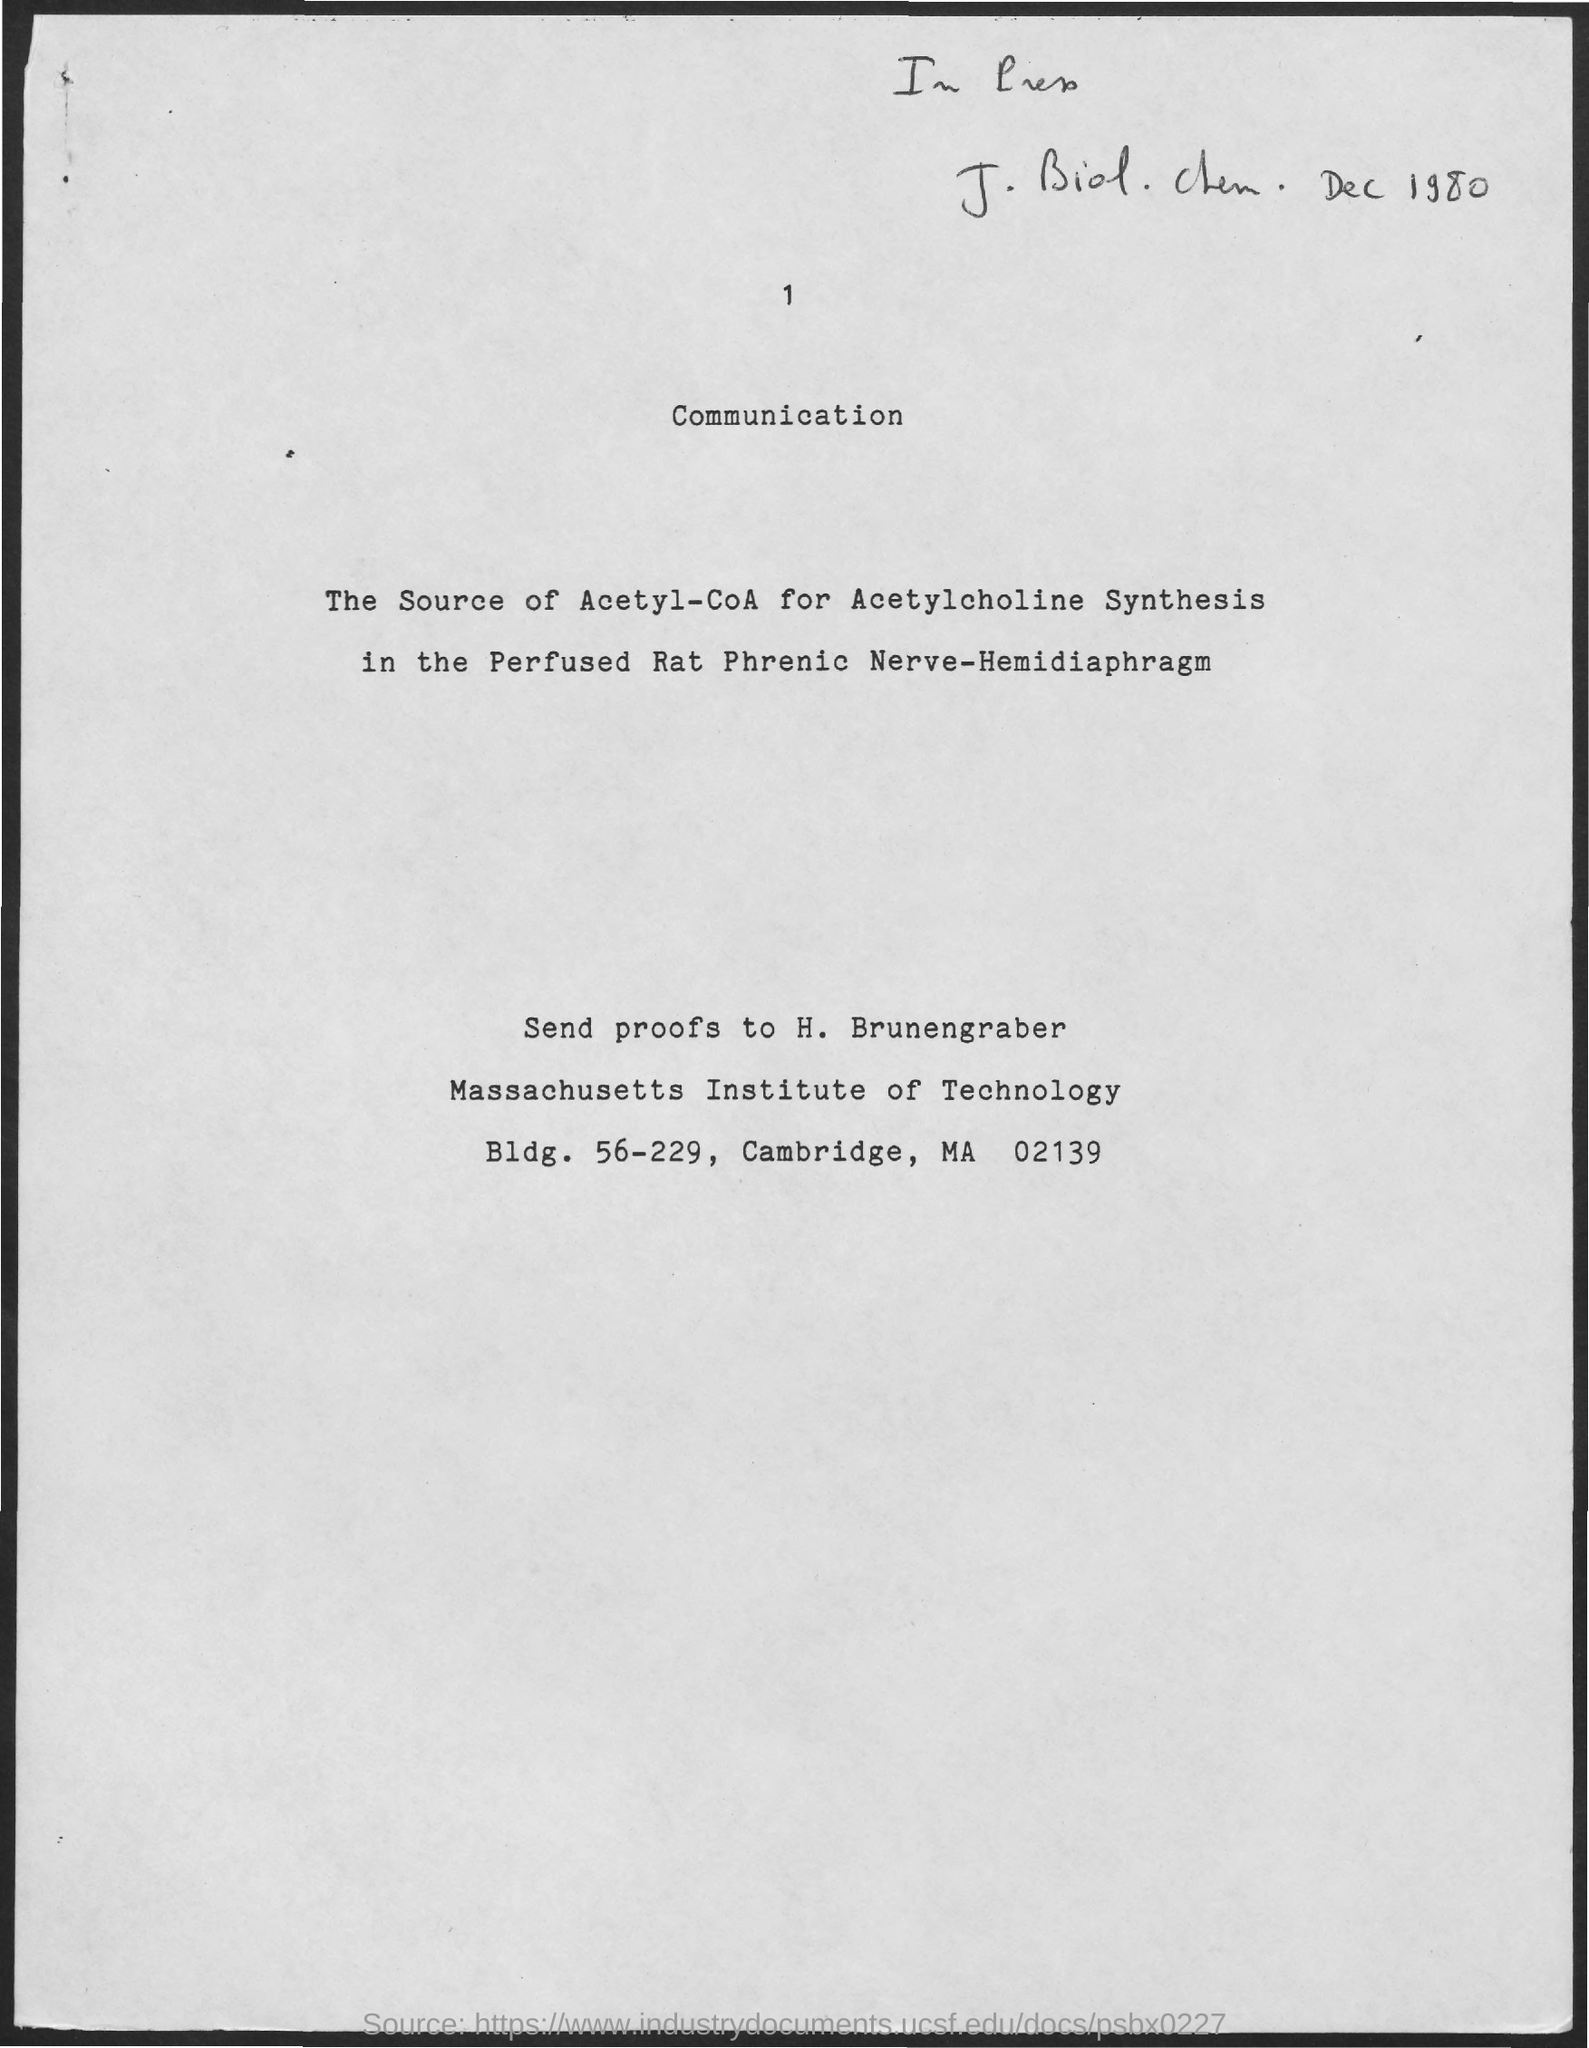Specify some key components in this picture. The page number at the top of the page is 1. The heading of the page is Communication. It is necessary for the proofs to be sent to H. Brunengraber. 